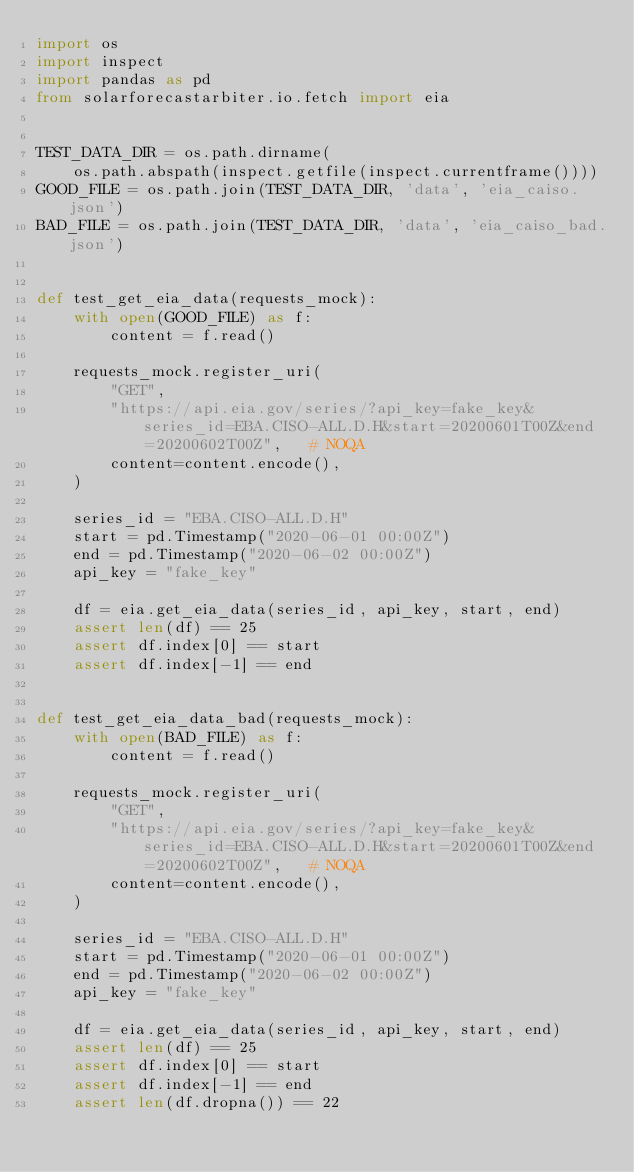<code> <loc_0><loc_0><loc_500><loc_500><_Python_>import os
import inspect
import pandas as pd
from solarforecastarbiter.io.fetch import eia


TEST_DATA_DIR = os.path.dirname(
    os.path.abspath(inspect.getfile(inspect.currentframe())))
GOOD_FILE = os.path.join(TEST_DATA_DIR, 'data', 'eia_caiso.json')
BAD_FILE = os.path.join(TEST_DATA_DIR, 'data', 'eia_caiso_bad.json')


def test_get_eia_data(requests_mock):
    with open(GOOD_FILE) as f:
        content = f.read()

    requests_mock.register_uri(
        "GET",
        "https://api.eia.gov/series/?api_key=fake_key&series_id=EBA.CISO-ALL.D.H&start=20200601T00Z&end=20200602T00Z",   # NOQA
        content=content.encode(),
    )

    series_id = "EBA.CISO-ALL.D.H"
    start = pd.Timestamp("2020-06-01 00:00Z")
    end = pd.Timestamp("2020-06-02 00:00Z")
    api_key = "fake_key"

    df = eia.get_eia_data(series_id, api_key, start, end)
    assert len(df) == 25
    assert df.index[0] == start
    assert df.index[-1] == end


def test_get_eia_data_bad(requests_mock):
    with open(BAD_FILE) as f:
        content = f.read()

    requests_mock.register_uri(
        "GET",
        "https://api.eia.gov/series/?api_key=fake_key&series_id=EBA.CISO-ALL.D.H&start=20200601T00Z&end=20200602T00Z",   # NOQA
        content=content.encode(),
    )

    series_id = "EBA.CISO-ALL.D.H"
    start = pd.Timestamp("2020-06-01 00:00Z")
    end = pd.Timestamp("2020-06-02 00:00Z")
    api_key = "fake_key"

    df = eia.get_eia_data(series_id, api_key, start, end)
    assert len(df) == 25
    assert df.index[0] == start
    assert df.index[-1] == end
    assert len(df.dropna()) == 22
</code> 